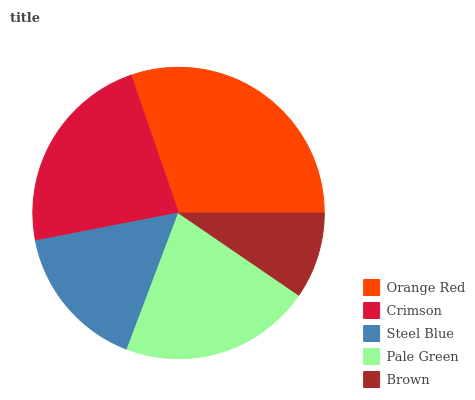Is Brown the minimum?
Answer yes or no. Yes. Is Orange Red the maximum?
Answer yes or no. Yes. Is Crimson the minimum?
Answer yes or no. No. Is Crimson the maximum?
Answer yes or no. No. Is Orange Red greater than Crimson?
Answer yes or no. Yes. Is Crimson less than Orange Red?
Answer yes or no. Yes. Is Crimson greater than Orange Red?
Answer yes or no. No. Is Orange Red less than Crimson?
Answer yes or no. No. Is Pale Green the high median?
Answer yes or no. Yes. Is Pale Green the low median?
Answer yes or no. Yes. Is Steel Blue the high median?
Answer yes or no. No. Is Crimson the low median?
Answer yes or no. No. 